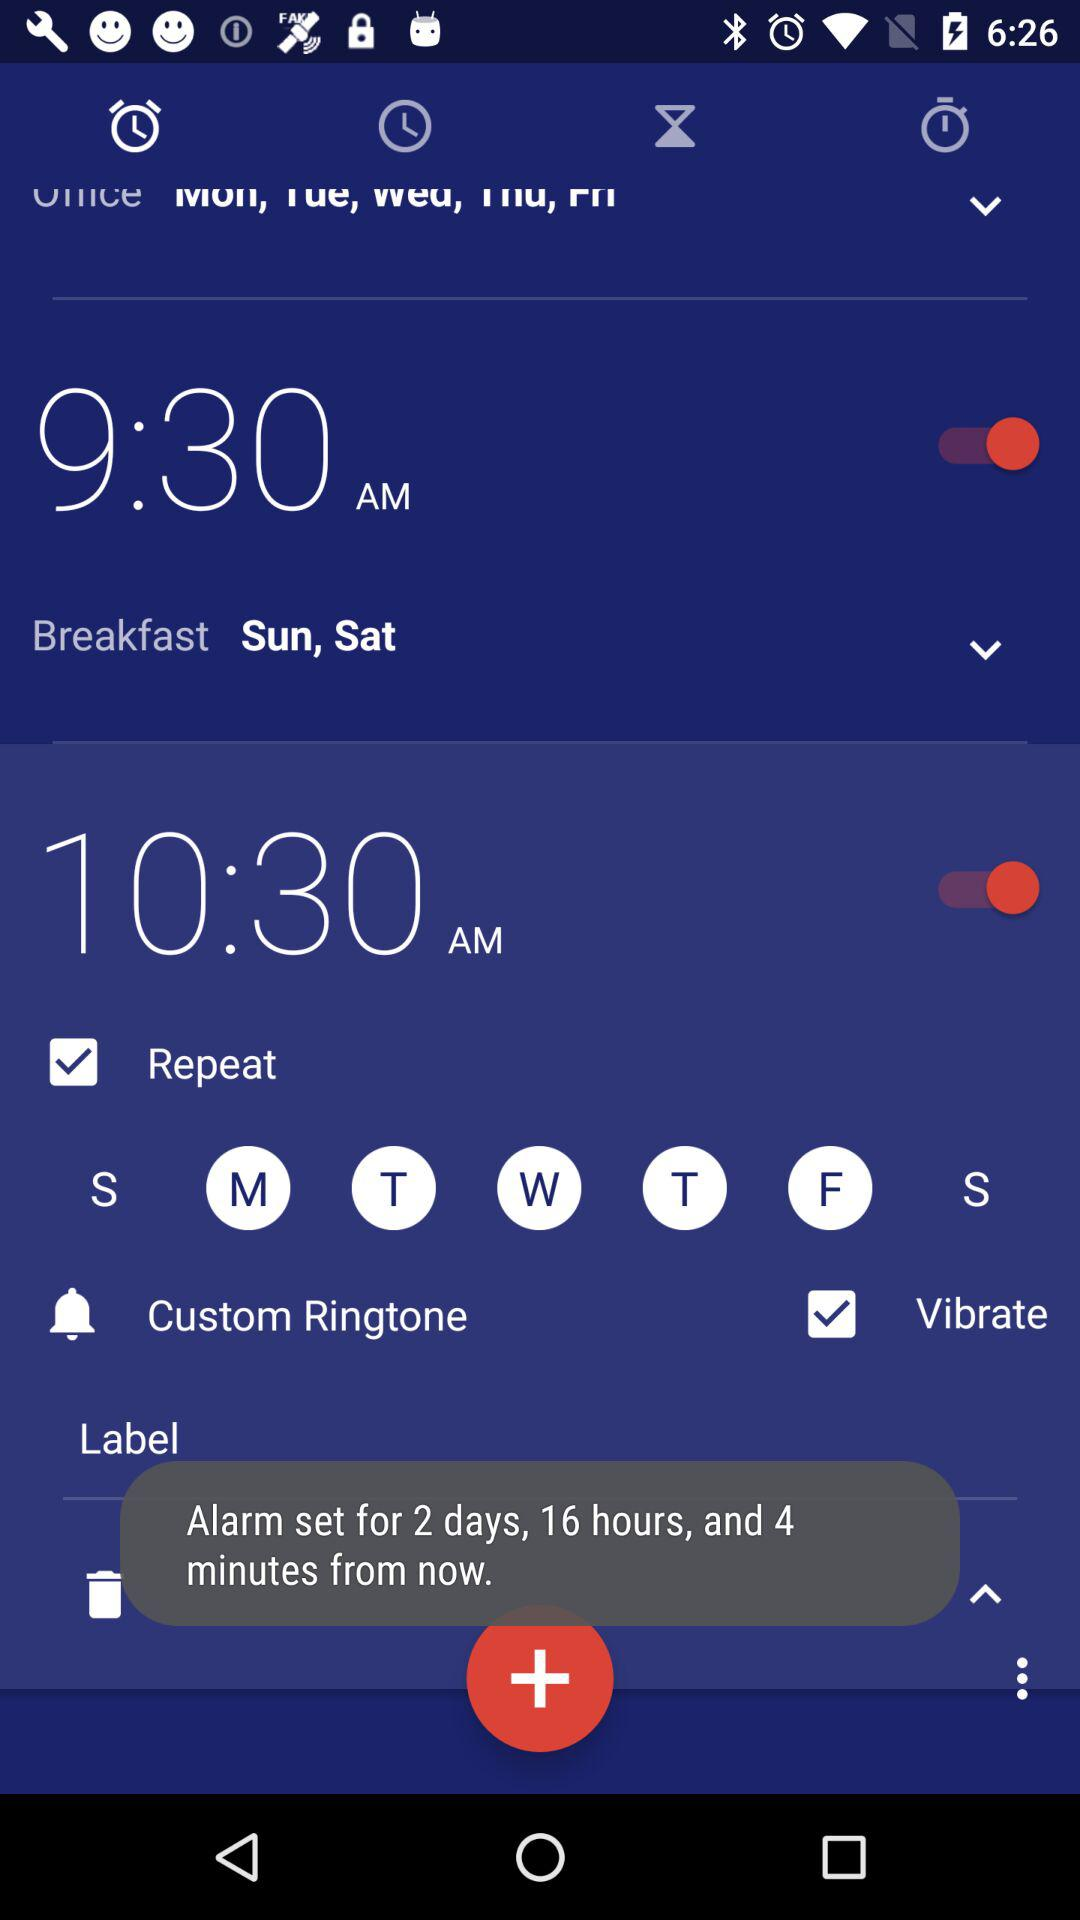How many days after now is the alarm set for?
Answer the question using a single word or phrase. 2 days 